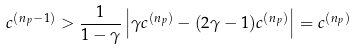Convert formula to latex. <formula><loc_0><loc_0><loc_500><loc_500>c ^ { ( n _ { p } - 1 ) } > \frac { 1 } { 1 - \gamma } \left | \gamma c ^ { ( n _ { p } ) } - ( 2 \gamma - 1 ) c ^ { ( n _ { p } ) } \right | = c ^ { ( n _ { p } ) }</formula> 